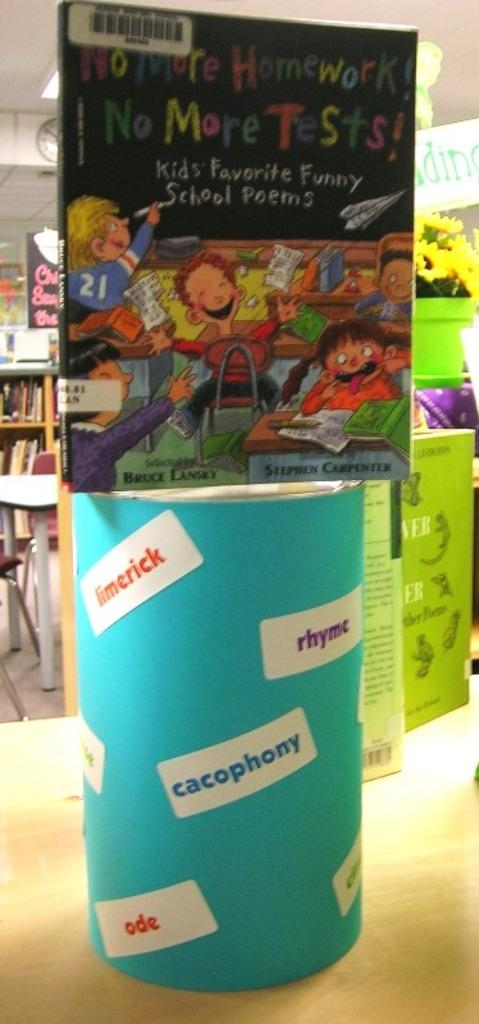Provide a one-sentence caption for the provided image. Book for children that is presenting No More Homework, No More Tests and Kids Favorite Funny School Poems. 